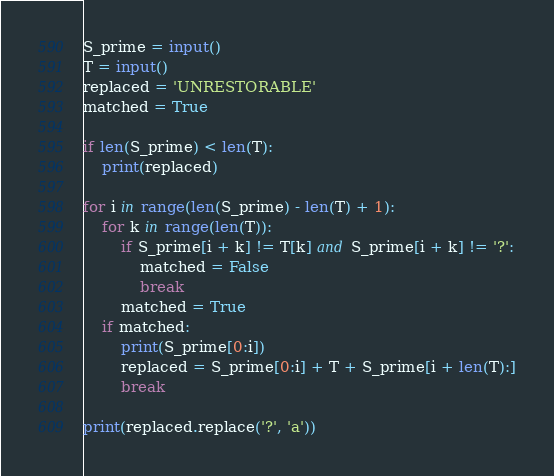Convert code to text. <code><loc_0><loc_0><loc_500><loc_500><_Python_>S_prime = input()
T = input()
replaced = 'UNRESTORABLE'
matched = True

if len(S_prime) < len(T):
    print(replaced)

for i in range(len(S_prime) - len(T) + 1):
    for k in range(len(T)):
        if S_prime[i + k] != T[k] and S_prime[i + k] != '?':
            matched = False
            break
        matched = True
    if matched:
        print(S_prime[0:i])
        replaced = S_prime[0:i] + T + S_prime[i + len(T):]
        break

print(replaced.replace('?', 'a'))
</code> 